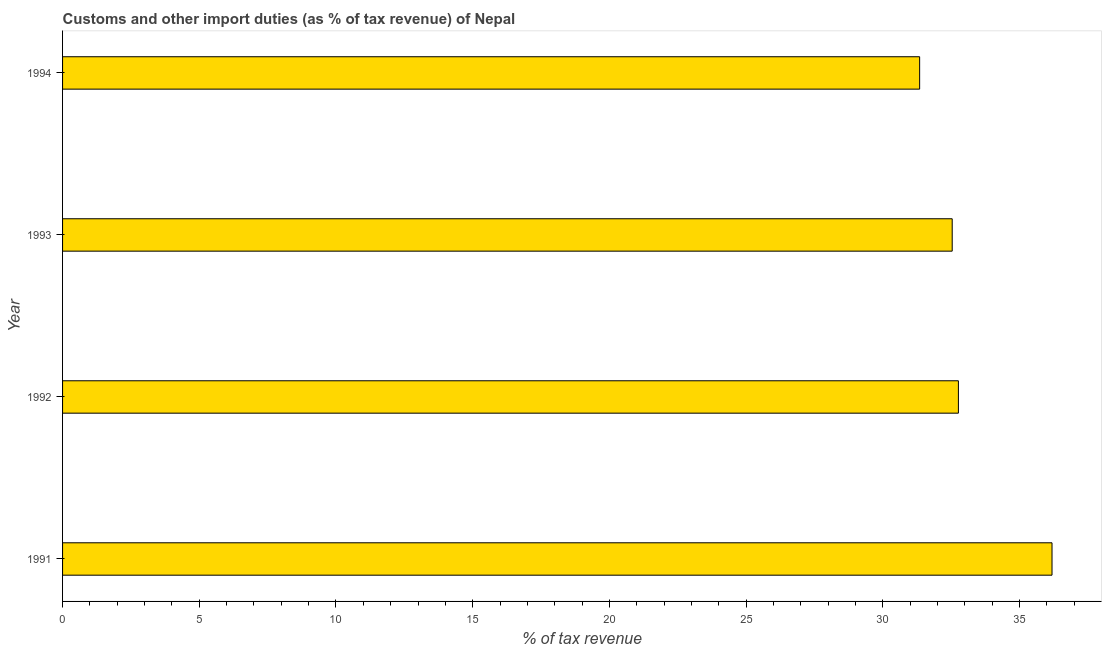What is the title of the graph?
Your response must be concise. Customs and other import duties (as % of tax revenue) of Nepal. What is the label or title of the X-axis?
Offer a very short reply. % of tax revenue. What is the label or title of the Y-axis?
Keep it short and to the point. Year. What is the customs and other import duties in 1993?
Give a very brief answer. 32.54. Across all years, what is the maximum customs and other import duties?
Keep it short and to the point. 36.19. Across all years, what is the minimum customs and other import duties?
Keep it short and to the point. 31.35. In which year was the customs and other import duties minimum?
Offer a terse response. 1994. What is the sum of the customs and other import duties?
Offer a terse response. 132.84. What is the difference between the customs and other import duties in 1993 and 1994?
Your answer should be very brief. 1.19. What is the average customs and other import duties per year?
Make the answer very short. 33.21. What is the median customs and other import duties?
Keep it short and to the point. 32.65. Do a majority of the years between 1991 and 1994 (inclusive) have customs and other import duties greater than 12 %?
Ensure brevity in your answer.  Yes. What is the ratio of the customs and other import duties in 1991 to that in 1992?
Offer a very short reply. 1.1. Is the customs and other import duties in 1991 less than that in 1992?
Your answer should be very brief. No. What is the difference between the highest and the second highest customs and other import duties?
Ensure brevity in your answer.  3.42. What is the difference between the highest and the lowest customs and other import duties?
Ensure brevity in your answer.  4.84. In how many years, is the customs and other import duties greater than the average customs and other import duties taken over all years?
Offer a very short reply. 1. How many bars are there?
Give a very brief answer. 4. How many years are there in the graph?
Keep it short and to the point. 4. What is the % of tax revenue of 1991?
Your answer should be compact. 36.19. What is the % of tax revenue in 1992?
Your response must be concise. 32.76. What is the % of tax revenue in 1993?
Your response must be concise. 32.54. What is the % of tax revenue of 1994?
Ensure brevity in your answer.  31.35. What is the difference between the % of tax revenue in 1991 and 1992?
Ensure brevity in your answer.  3.42. What is the difference between the % of tax revenue in 1991 and 1993?
Make the answer very short. 3.65. What is the difference between the % of tax revenue in 1991 and 1994?
Your answer should be compact. 4.84. What is the difference between the % of tax revenue in 1992 and 1993?
Your response must be concise. 0.23. What is the difference between the % of tax revenue in 1992 and 1994?
Offer a terse response. 1.42. What is the difference between the % of tax revenue in 1993 and 1994?
Your answer should be very brief. 1.19. What is the ratio of the % of tax revenue in 1991 to that in 1992?
Ensure brevity in your answer.  1.1. What is the ratio of the % of tax revenue in 1991 to that in 1993?
Offer a terse response. 1.11. What is the ratio of the % of tax revenue in 1991 to that in 1994?
Provide a short and direct response. 1.15. What is the ratio of the % of tax revenue in 1992 to that in 1993?
Provide a short and direct response. 1.01. What is the ratio of the % of tax revenue in 1992 to that in 1994?
Your answer should be compact. 1.04. What is the ratio of the % of tax revenue in 1993 to that in 1994?
Your answer should be very brief. 1.04. 